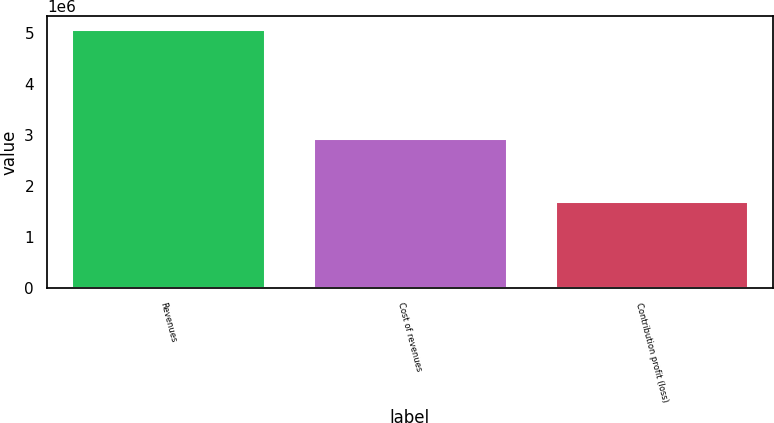<chart> <loc_0><loc_0><loc_500><loc_500><bar_chart><fcel>Revenues<fcel>Cost of revenues<fcel>Contribution profit (loss)<nl><fcel>5.07731e+06<fcel>2.95197e+06<fcel>1.71241e+06<nl></chart> 